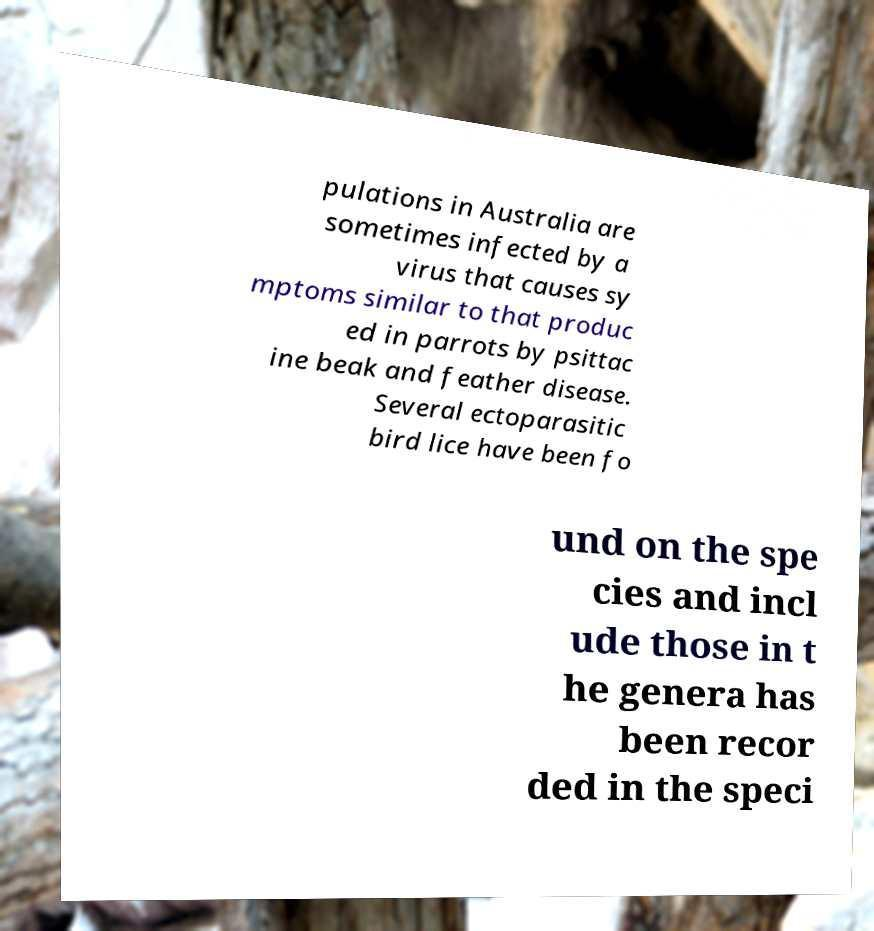There's text embedded in this image that I need extracted. Can you transcribe it verbatim? pulations in Australia are sometimes infected by a virus that causes sy mptoms similar to that produc ed in parrots by psittac ine beak and feather disease. Several ectoparasitic bird lice have been fo und on the spe cies and incl ude those in t he genera has been recor ded in the speci 